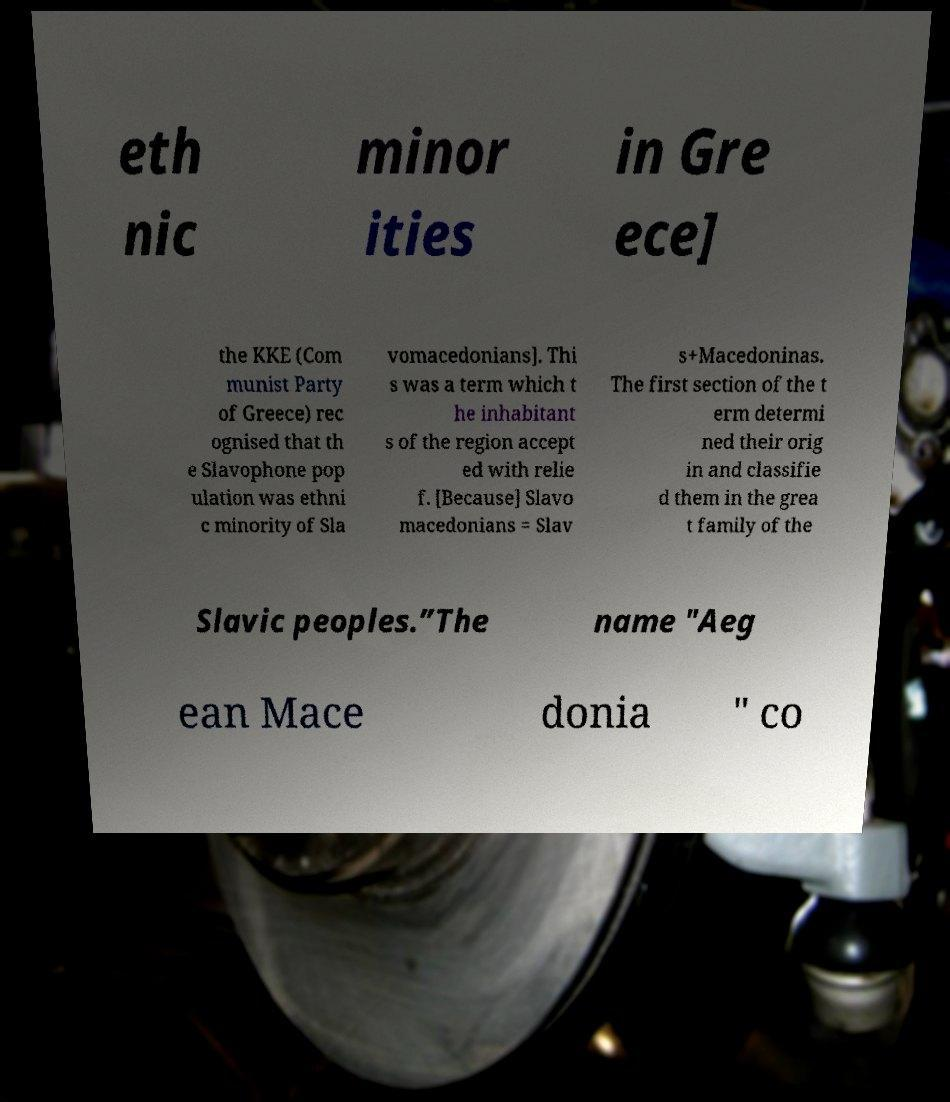I need the written content from this picture converted into text. Can you do that? eth nic minor ities in Gre ece] the KKE (Com munist Party of Greece) rec ognised that th e Slavophone pop ulation was ethni c minority of Sla vomacedonians]. Thi s was a term which t he inhabitant s of the region accept ed with relie f. [Because] Slavo macedonians = Slav s+Macedoninas. The first section of the t erm determi ned their orig in and classifie d them in the grea t family of the Slavic peoples.”The name "Aeg ean Mace donia " co 